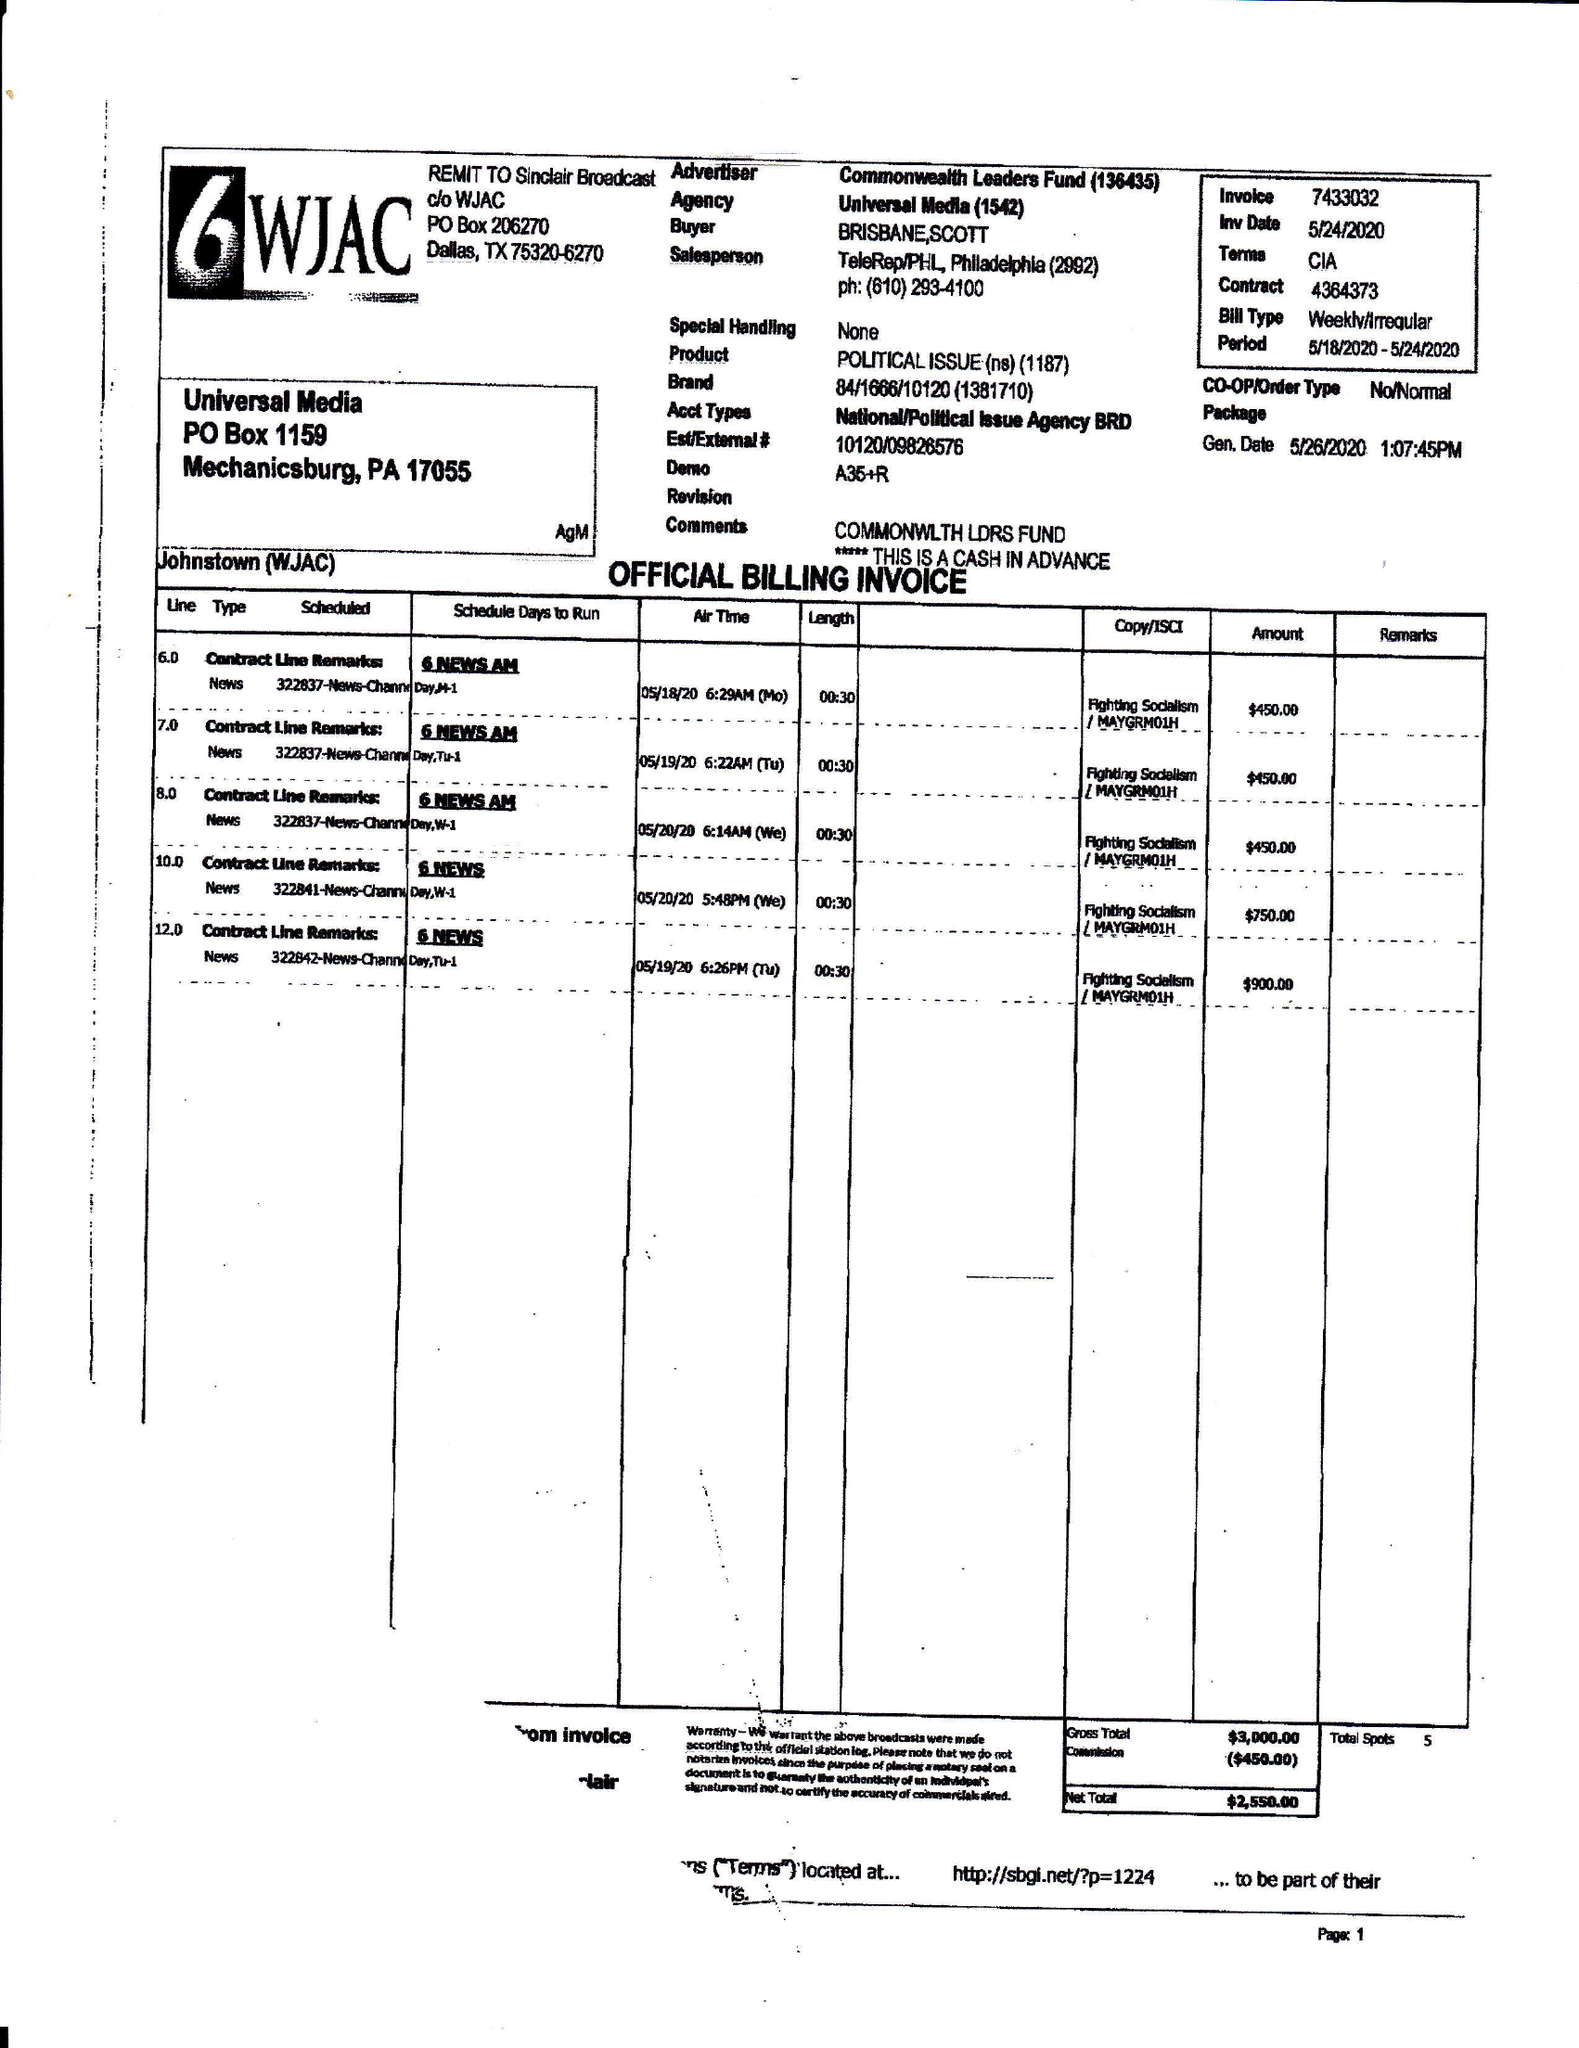What is the value for the contract_num?
Answer the question using a single word or phrase. 4364373 